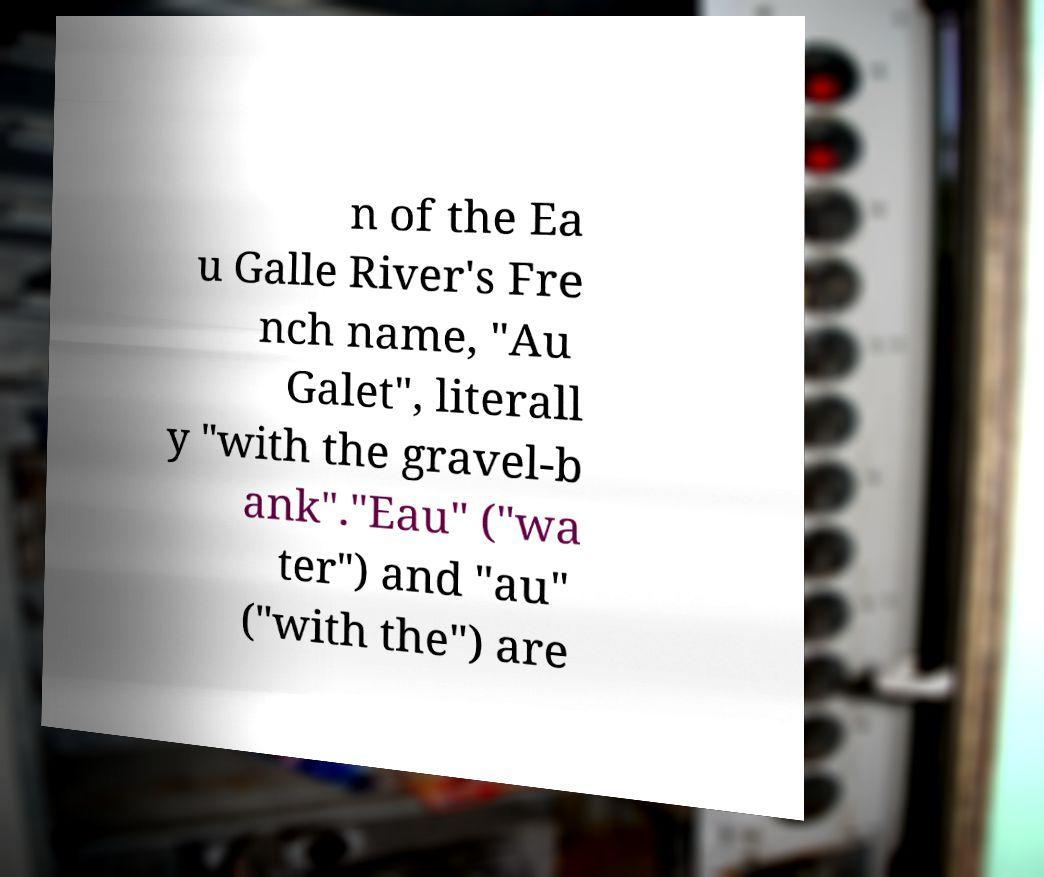There's text embedded in this image that I need extracted. Can you transcribe it verbatim? n of the Ea u Galle River's Fre nch name, "Au Galet", literall y "with the gravel-b ank"."Eau" ("wa ter") and "au" ("with the") are 